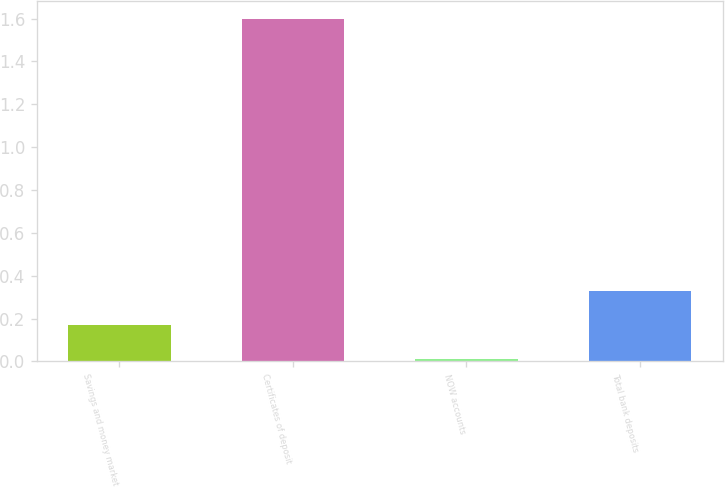Convert chart to OTSL. <chart><loc_0><loc_0><loc_500><loc_500><bar_chart><fcel>Savings and money market<fcel>Certificates of deposit<fcel>NOW accounts<fcel>Total bank deposits<nl><fcel>0.17<fcel>1.6<fcel>0.01<fcel>0.33<nl></chart> 